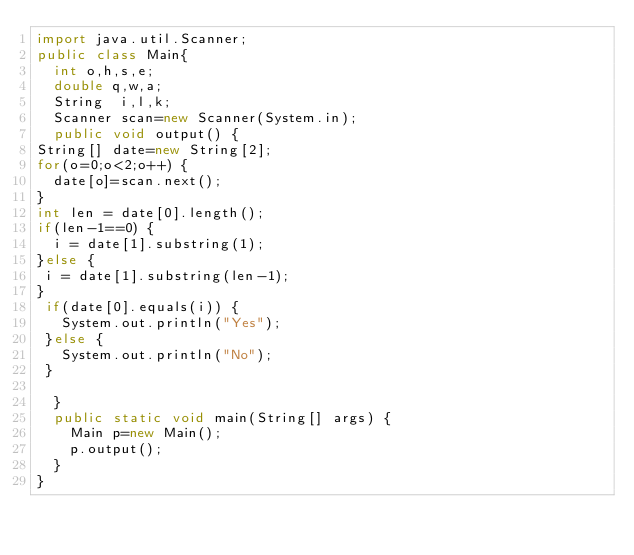<code> <loc_0><loc_0><loc_500><loc_500><_Java_>import java.util.Scanner;
public class Main{
	int o,h,s,e;
	double q,w,a;
	String  i,l,k;
	Scanner scan=new Scanner(System.in);
	public void output() {
String[] date=new String[2];
for(o=0;o<2;o++) {
	date[o]=scan.next();
}
int len = date[0].length();
if(len-1==0) {
	i = date[1].substring(1);
}else {
 i = date[1].substring(len-1);
}
 if(date[0].equals(i)) {
	 System.out.println("Yes");
 }else {
	 System.out.println("No");
 }

	}
	public static void main(String[] args) {
		Main p=new Main();
		p.output();
	}
}</code> 